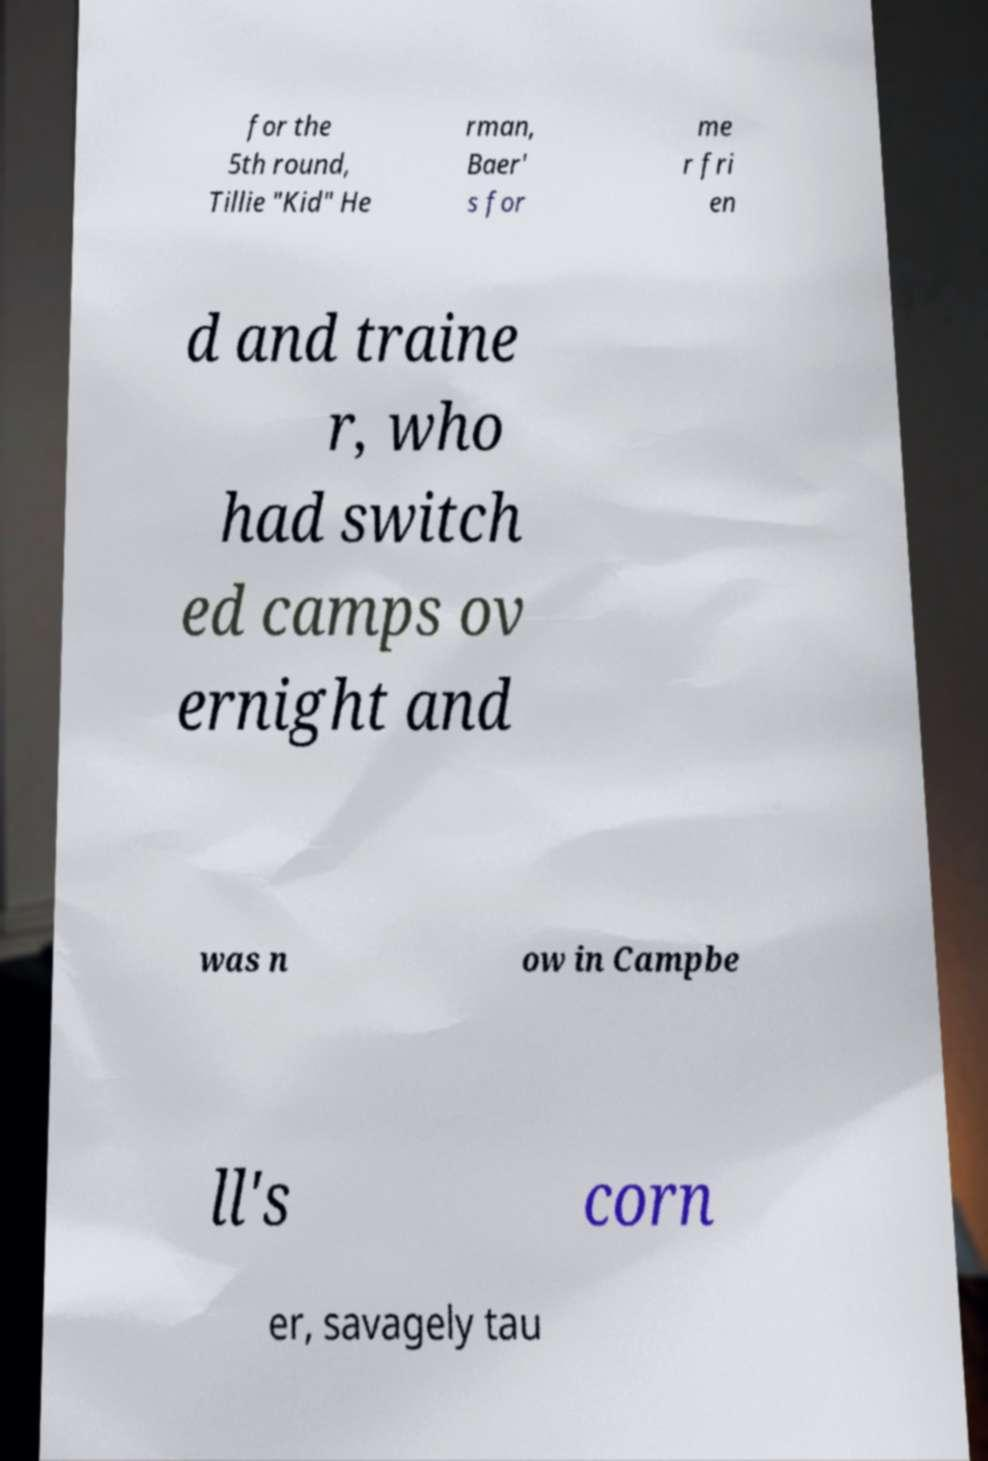I need the written content from this picture converted into text. Can you do that? for the 5th round, Tillie "Kid" He rman, Baer' s for me r fri en d and traine r, who had switch ed camps ov ernight and was n ow in Campbe ll's corn er, savagely tau 